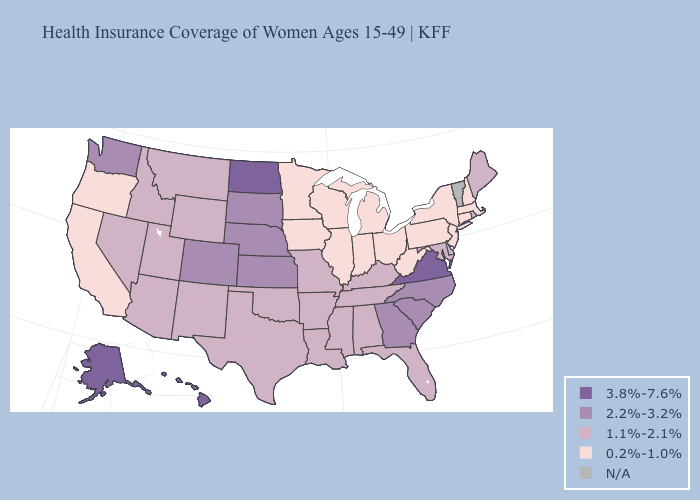Which states hav the highest value in the West?
Answer briefly. Alaska, Hawaii. Does West Virginia have the lowest value in the South?
Be succinct. Yes. What is the value of Minnesota?
Give a very brief answer. 0.2%-1.0%. Among the states that border New Hampshire , does Massachusetts have the lowest value?
Short answer required. Yes. What is the value of Delaware?
Short answer required. 1.1%-2.1%. What is the lowest value in the USA?
Concise answer only. 0.2%-1.0%. Name the states that have a value in the range 1.1%-2.1%?
Give a very brief answer. Alabama, Arizona, Arkansas, Delaware, Florida, Idaho, Kentucky, Louisiana, Maine, Maryland, Mississippi, Missouri, Montana, Nevada, New Mexico, Oklahoma, Rhode Island, Tennessee, Texas, Utah, Wyoming. Name the states that have a value in the range N/A?
Write a very short answer. Vermont. Which states have the highest value in the USA?
Short answer required. Alaska, Hawaii, North Dakota, Virginia. What is the value of Arizona?
Short answer required. 1.1%-2.1%. Which states have the lowest value in the South?
Write a very short answer. West Virginia. What is the value of Michigan?
Answer briefly. 0.2%-1.0%. Is the legend a continuous bar?
Keep it brief. No. Name the states that have a value in the range 1.1%-2.1%?
Short answer required. Alabama, Arizona, Arkansas, Delaware, Florida, Idaho, Kentucky, Louisiana, Maine, Maryland, Mississippi, Missouri, Montana, Nevada, New Mexico, Oklahoma, Rhode Island, Tennessee, Texas, Utah, Wyoming. 